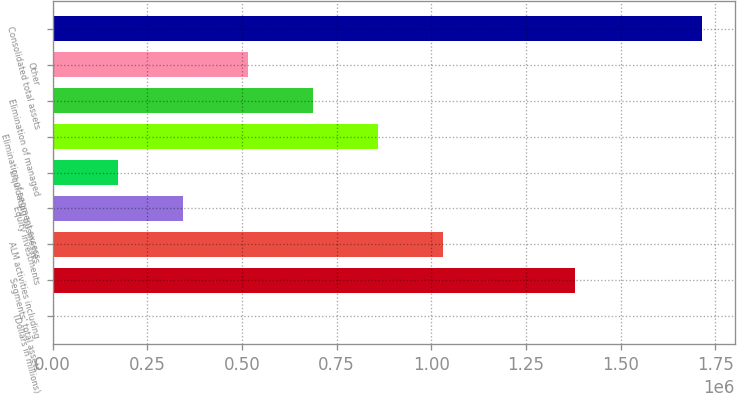Convert chart to OTSL. <chart><loc_0><loc_0><loc_500><loc_500><bar_chart><fcel>(Dollars in millions)<fcel>Segments' total assets<fcel>ALM activities including<fcel>Equity investments<fcel>Liquidating businesses<fcel>Elimination of segment excess<fcel>Elimination of managed<fcel>Other<fcel>Consolidated total assets<nl><fcel>2007<fcel>1.37916e+06<fcel>1.03025e+06<fcel>344755<fcel>173381<fcel>858876<fcel>687503<fcel>516129<fcel>1.71575e+06<nl></chart> 